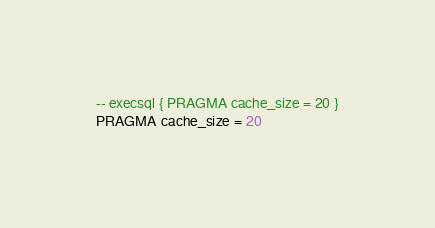Convert code to text. <code><loc_0><loc_0><loc_500><loc_500><_SQL_>-- execsql { PRAGMA cache_size = 20 }
PRAGMA cache_size = 20</code> 